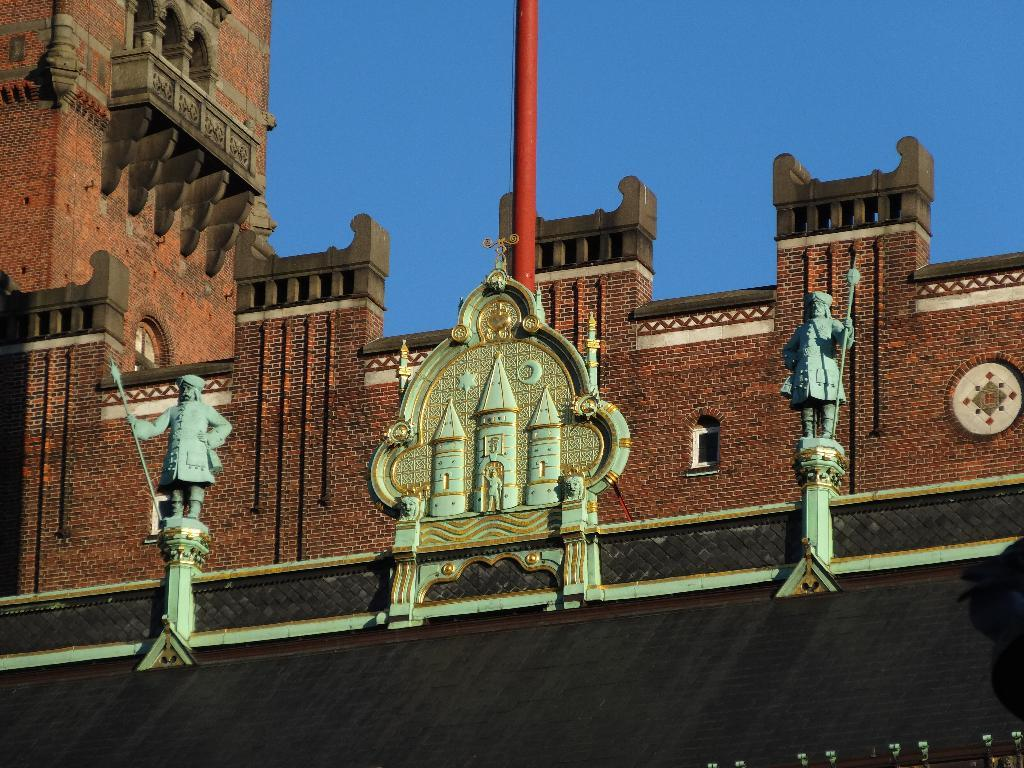What is the main subject of the image? The main subject of the image is the front view of a building. Are there any additional features or objects in the image? Yes, there are two sculptures and a pink color pole in the middle of the image. What is the color of the sky in the image? The sky is blue in color. How many leaves can be seen on the bikes in the image? There are no bikes present in the image, so there are no leaves to count. 